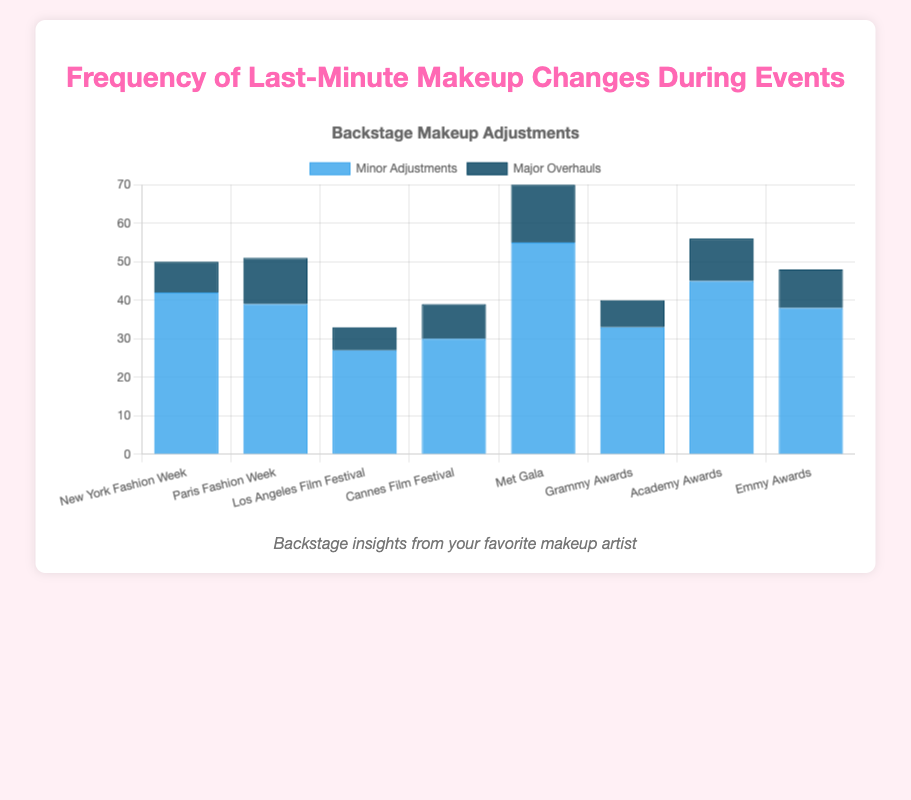What's the event with the highest number of minor adjustments? Look at the "Minor Adjustments" category and identify the tallest bar. The tallest bar is for the Met Gala.
Answer: Met Gala How many minor adjustments were made at the Grammy Awards? Check the height of the bar labeled "Grammy Awards" under the "Minor Adjustments" category.
Answer: 33 Which event had more major overhauls than minor adjustments? Compare the heights of the bars for each event. None of the events have a taller bar for "Major Overhauls" than "Minor Adjustments."
Answer: None What's the total number of major overhauls made during the New York and Paris Fashion Weeks? Add the number of major overhauls for New York and Paris Fashion Weeks: 8 (New York) + 12 (Paris).
Answer: 20 How many more minor adjustments were made at the Met Gala compared to the Los Angeles Film Festival? Subtract the number of minor adjustments at the Los Angeles Film Festival from those at the Met Gala: 55 - 27.
Answer: 28 Which event had the fewest major overhauls? Identify the shortest bar in the "Major Overhauls" category. The Los Angeles Film Festival has the shortest bar.
Answer: Los Angeles Film Festival What’s the difference in the number of major overhauls between Cannes Film Festival and Academy Awards? Subtract the number of major overhauls for Cannes from those for Academy Awards: 11 - 9.
Answer: 2 How many total adjustments (minor + major) were made at the Emmy Awards? Add the number of minor adjustments and major overhauls at the Emmy Awards: 38 (minor) + 10 (major).
Answer: 48 What's the average number of minor adjustments made across all events? Calculate the average by summing all minor adjustments and dividing by the number of events. (42 + 39 + 27 + 30 + 55 + 33 + 45 + 38) / 8.
Answer: 38.625 What is the combined total of major overhauls across all events? Sum all the major overhauls from each event: 8 + 12 + 6 + 9 + 15 + 7 + 11 + 10.
Answer: 78 